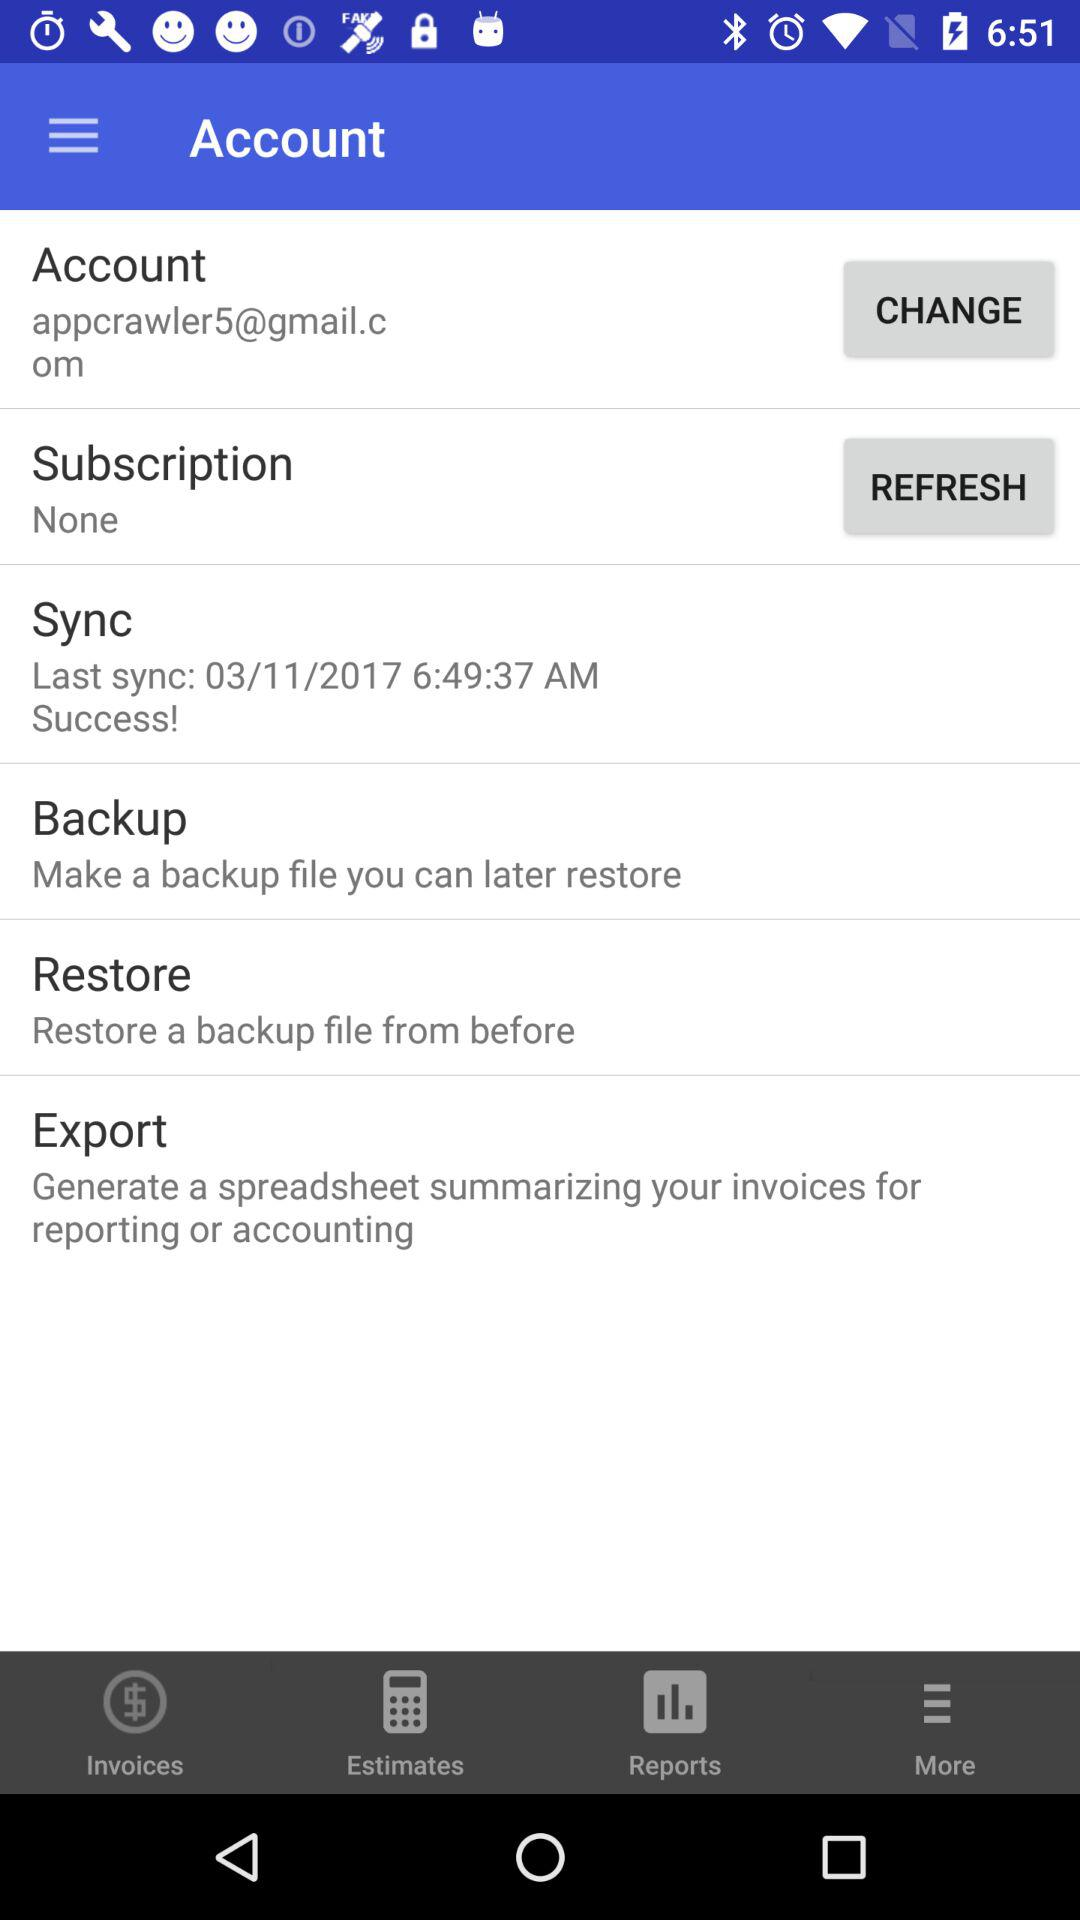When was the application synced last time? The application was last synced on March 11, 2017 at 6:49:37 AM. 